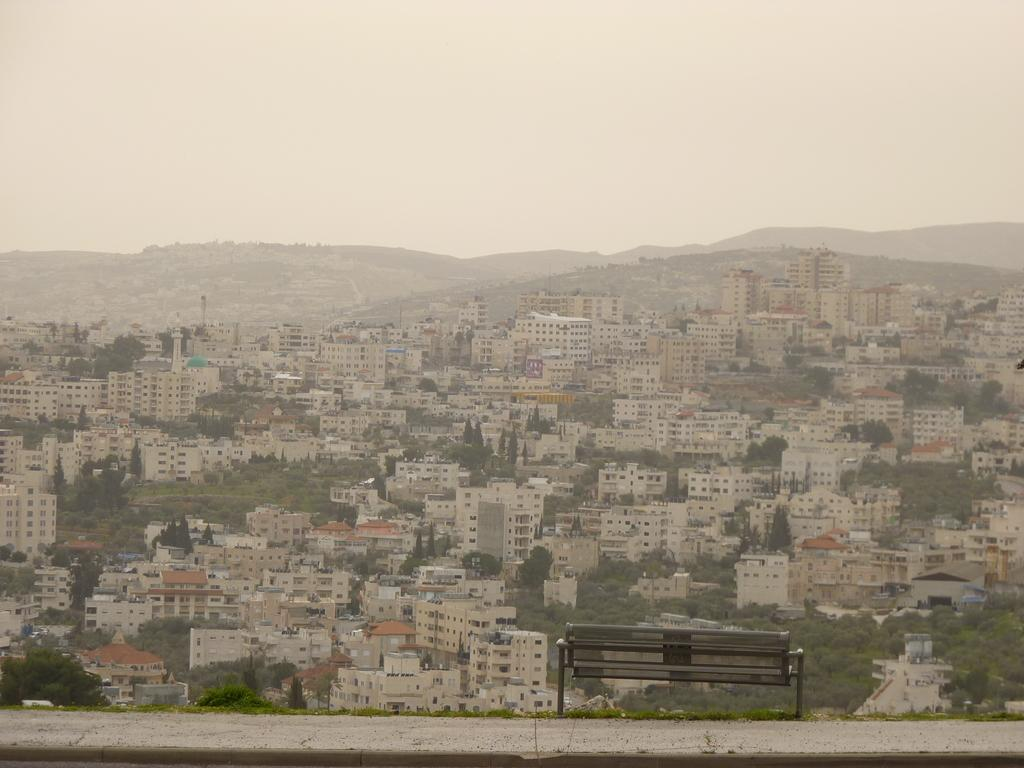What is located on the ground in the image? There is a bench on the ground in the image. What can be seen in the background of the image? Buildings, trees, poles, hills, and vehicles are present in the background of the image. What is visible at the top of the image? The sky is visible at the top of the image. Can you see any chess pieces on the bench in the image? There are no chess pieces visible on the bench in the image. Does the image show someone sneezing? There is no indication of anyone sneezing in the image. 